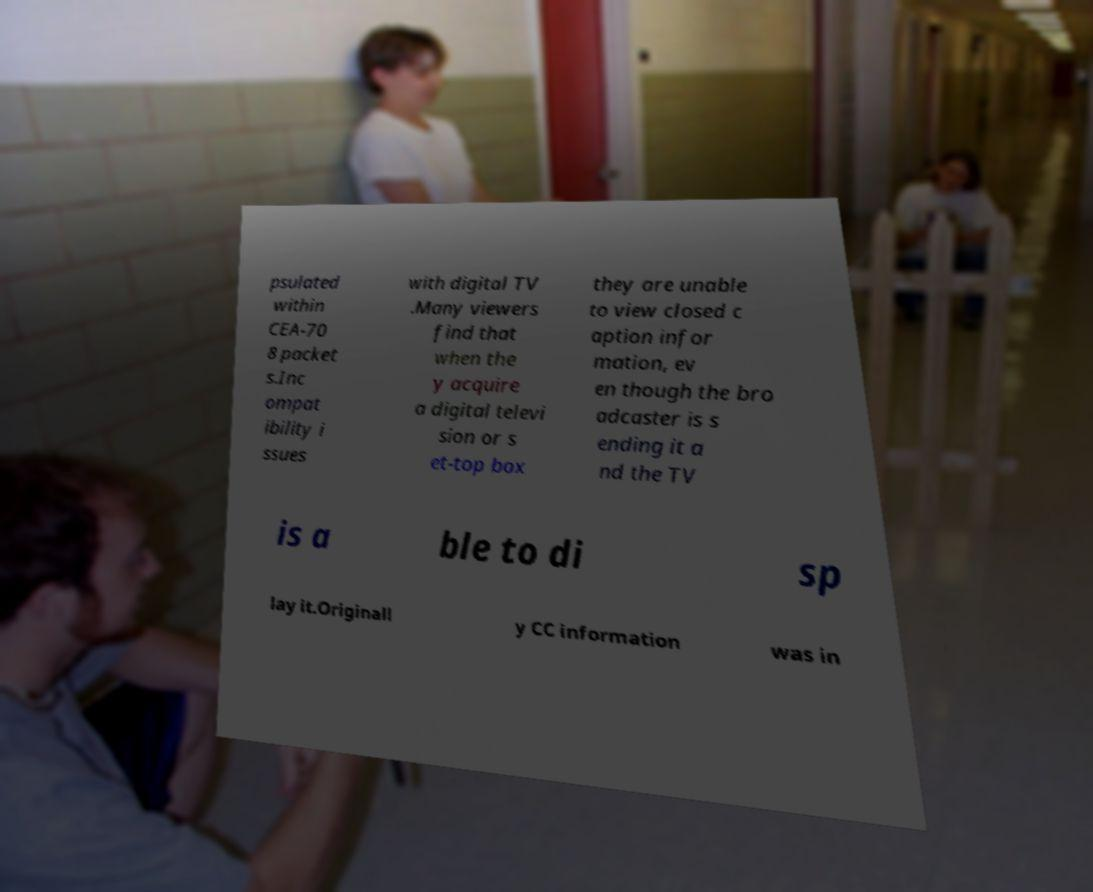Could you assist in decoding the text presented in this image and type it out clearly? psulated within CEA-70 8 packet s.Inc ompat ibility i ssues with digital TV .Many viewers find that when the y acquire a digital televi sion or s et-top box they are unable to view closed c aption infor mation, ev en though the bro adcaster is s ending it a nd the TV is a ble to di sp lay it.Originall y CC information was in 